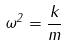Convert formula to latex. <formula><loc_0><loc_0><loc_500><loc_500>\omega ^ { 2 } = \frac { k } { m }</formula> 